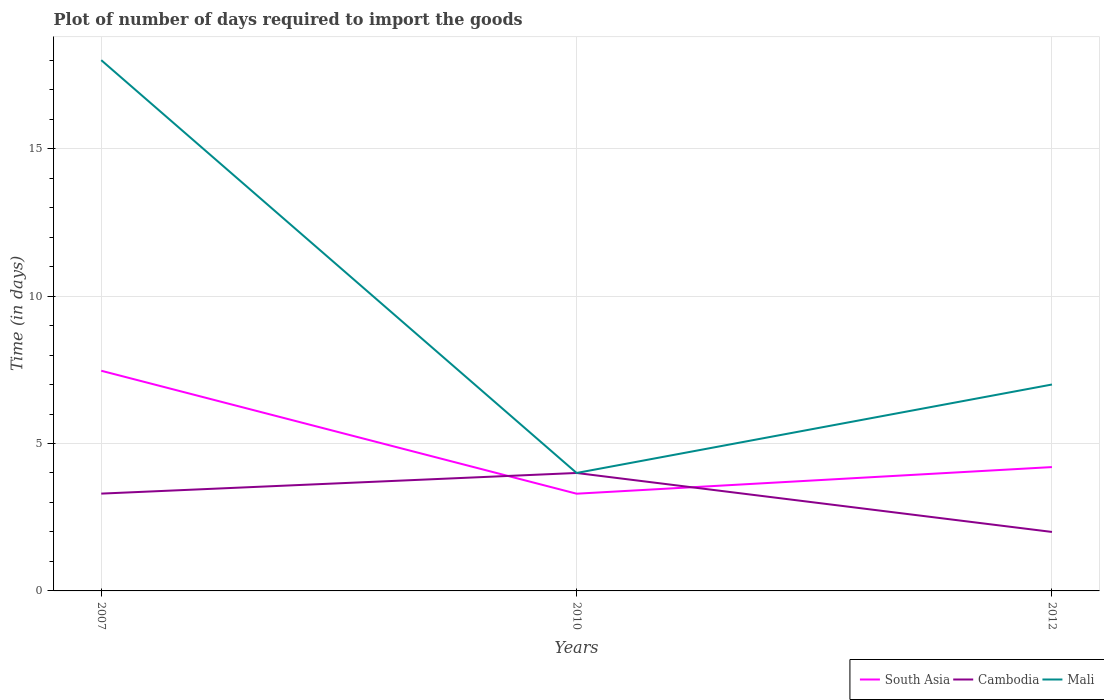Does the line corresponding to Mali intersect with the line corresponding to Cambodia?
Make the answer very short. Yes. Across all years, what is the maximum time required to import goods in South Asia?
Give a very brief answer. 3.3. In which year was the time required to import goods in Cambodia maximum?
Ensure brevity in your answer.  2012. What is the total time required to import goods in South Asia in the graph?
Ensure brevity in your answer.  -0.9. What is the difference between the highest and the second highest time required to import goods in South Asia?
Keep it short and to the point. 4.17. What is the difference between the highest and the lowest time required to import goods in Cambodia?
Your response must be concise. 2. Is the time required to import goods in Cambodia strictly greater than the time required to import goods in South Asia over the years?
Your answer should be compact. No. What is the difference between two consecutive major ticks on the Y-axis?
Your answer should be compact. 5. Are the values on the major ticks of Y-axis written in scientific E-notation?
Make the answer very short. No. Does the graph contain any zero values?
Your answer should be compact. No. Where does the legend appear in the graph?
Make the answer very short. Bottom right. What is the title of the graph?
Ensure brevity in your answer.  Plot of number of days required to import the goods. Does "New Caledonia" appear as one of the legend labels in the graph?
Offer a terse response. No. What is the label or title of the Y-axis?
Give a very brief answer. Time (in days). What is the Time (in days) of South Asia in 2007?
Keep it short and to the point. 7.47. What is the Time (in days) in South Asia in 2010?
Your response must be concise. 3.3. What is the Time (in days) of Cambodia in 2010?
Your response must be concise. 4. What is the Time (in days) of Cambodia in 2012?
Your answer should be compact. 2. What is the Time (in days) in Mali in 2012?
Provide a short and direct response. 7. Across all years, what is the maximum Time (in days) of South Asia?
Your answer should be compact. 7.47. Across all years, what is the minimum Time (in days) in South Asia?
Keep it short and to the point. 3.3. What is the total Time (in days) of South Asia in the graph?
Give a very brief answer. 14.96. What is the difference between the Time (in days) of South Asia in 2007 and that in 2010?
Keep it short and to the point. 4.17. What is the difference between the Time (in days) in South Asia in 2007 and that in 2012?
Offer a terse response. 3.27. What is the difference between the Time (in days) of Mali in 2007 and that in 2012?
Keep it short and to the point. 11. What is the difference between the Time (in days) of South Asia in 2010 and that in 2012?
Your answer should be very brief. -0.9. What is the difference between the Time (in days) in Cambodia in 2010 and that in 2012?
Keep it short and to the point. 2. What is the difference between the Time (in days) of Mali in 2010 and that in 2012?
Your response must be concise. -3. What is the difference between the Time (in days) in South Asia in 2007 and the Time (in days) in Cambodia in 2010?
Offer a very short reply. 3.47. What is the difference between the Time (in days) in South Asia in 2007 and the Time (in days) in Mali in 2010?
Make the answer very short. 3.47. What is the difference between the Time (in days) of Cambodia in 2007 and the Time (in days) of Mali in 2010?
Offer a very short reply. -0.7. What is the difference between the Time (in days) in South Asia in 2007 and the Time (in days) in Cambodia in 2012?
Ensure brevity in your answer.  5.47. What is the difference between the Time (in days) in South Asia in 2007 and the Time (in days) in Mali in 2012?
Your response must be concise. 0.47. What is the difference between the Time (in days) of South Asia in 2010 and the Time (in days) of Cambodia in 2012?
Make the answer very short. 1.3. What is the difference between the Time (in days) of South Asia in 2010 and the Time (in days) of Mali in 2012?
Ensure brevity in your answer.  -3.7. What is the difference between the Time (in days) in Cambodia in 2010 and the Time (in days) in Mali in 2012?
Your response must be concise. -3. What is the average Time (in days) of South Asia per year?
Make the answer very short. 4.99. What is the average Time (in days) of Cambodia per year?
Ensure brevity in your answer.  3.1. What is the average Time (in days) of Mali per year?
Give a very brief answer. 9.67. In the year 2007, what is the difference between the Time (in days) in South Asia and Time (in days) in Cambodia?
Offer a very short reply. 4.17. In the year 2007, what is the difference between the Time (in days) in South Asia and Time (in days) in Mali?
Provide a succinct answer. -10.53. In the year 2007, what is the difference between the Time (in days) of Cambodia and Time (in days) of Mali?
Your answer should be very brief. -14.7. In the year 2010, what is the difference between the Time (in days) in South Asia and Time (in days) in Cambodia?
Keep it short and to the point. -0.7. In the year 2010, what is the difference between the Time (in days) of South Asia and Time (in days) of Mali?
Make the answer very short. -0.7. In the year 2012, what is the difference between the Time (in days) of South Asia and Time (in days) of Cambodia?
Provide a short and direct response. 2.2. In the year 2012, what is the difference between the Time (in days) of South Asia and Time (in days) of Mali?
Make the answer very short. -2.8. What is the ratio of the Time (in days) of South Asia in 2007 to that in 2010?
Give a very brief answer. 2.26. What is the ratio of the Time (in days) in Cambodia in 2007 to that in 2010?
Offer a terse response. 0.82. What is the ratio of the Time (in days) of South Asia in 2007 to that in 2012?
Provide a succinct answer. 1.78. What is the ratio of the Time (in days) of Cambodia in 2007 to that in 2012?
Provide a succinct answer. 1.65. What is the ratio of the Time (in days) of Mali in 2007 to that in 2012?
Offer a very short reply. 2.57. What is the ratio of the Time (in days) of South Asia in 2010 to that in 2012?
Your answer should be very brief. 0.79. What is the ratio of the Time (in days) of Cambodia in 2010 to that in 2012?
Offer a very short reply. 2. What is the difference between the highest and the second highest Time (in days) in South Asia?
Ensure brevity in your answer.  3.27. What is the difference between the highest and the second highest Time (in days) of Cambodia?
Offer a very short reply. 0.7. What is the difference between the highest and the second highest Time (in days) of Mali?
Your answer should be compact. 11. What is the difference between the highest and the lowest Time (in days) of South Asia?
Your response must be concise. 4.17. 